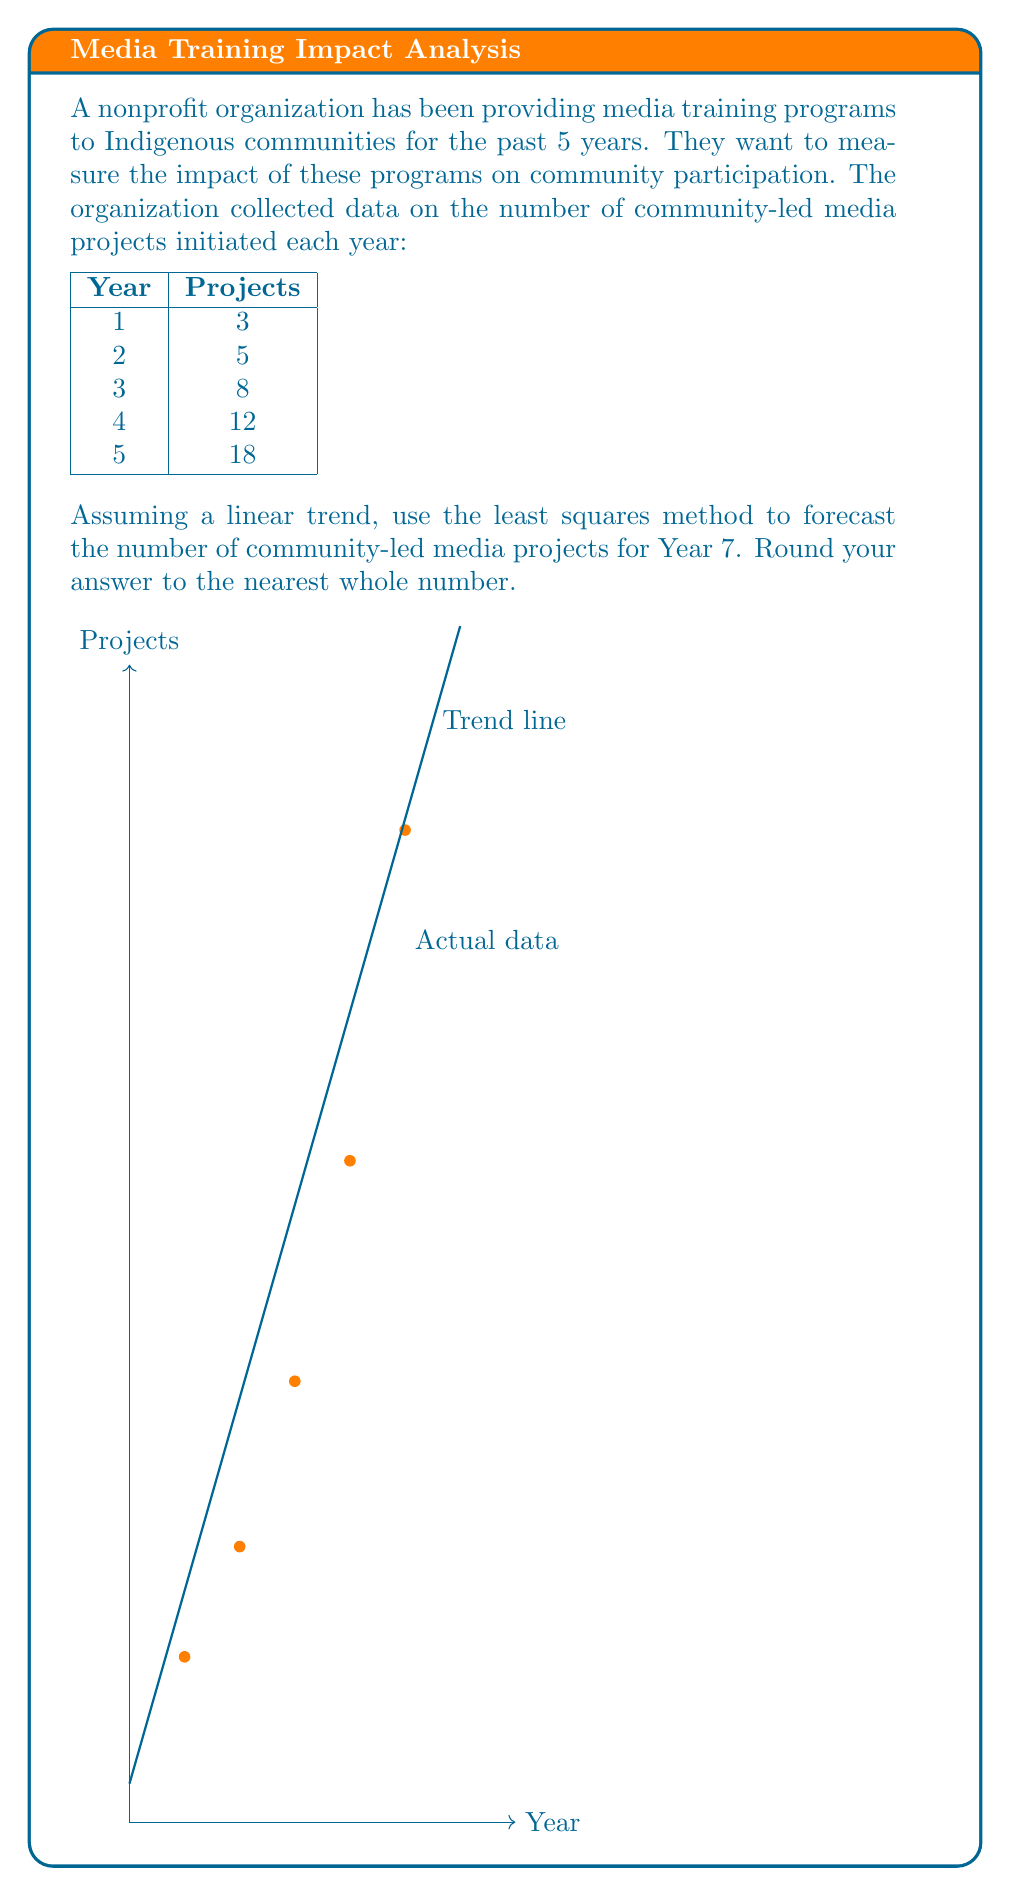Solve this math problem. To solve this problem using the least squares method, we'll follow these steps:

1) Let $x$ represent the year (1-5) and $y$ represent the number of projects.

2) Calculate the means:
   $\bar{x} = \frac{1+2+3+4+5}{5} = 3$
   $\bar{y} = \frac{3+5+8+12+18}{5} = 9.2$

3) Calculate $\sum(x-\bar{x})(y-\bar{y})$ and $\sum(x-\bar{x})^2$:

   $\sum(x-\bar{x})(y-\bar{y}) = (-2)(-6.2) + (-1)(-4.2) + (0)(-1.2) + (1)(2.8) + (2)(8.8) = 35$

   $\sum(x-\bar{x})^2 = (-2)^2 + (-1)^2 + 0^2 + 1^2 + 2^2 = 10$

4) Calculate the slope $b$:
   $b = \frac{\sum(x-\bar{x})(y-\bar{y})}{\sum(x-\bar{x})^2} = \frac{35}{10} = 3.5$

5) Calculate the y-intercept $a$:
   $a = \bar{y} - b\bar{x} = 9.2 - 3.5(3) = -1.3$

6) The linear equation is $y = 3.5x - 1.3$

7) For Year 7, $x = 7$:
   $y = 3.5(7) - 1.3 = 23.2$

8) Rounding to the nearest whole number: 23
Answer: 23 projects 